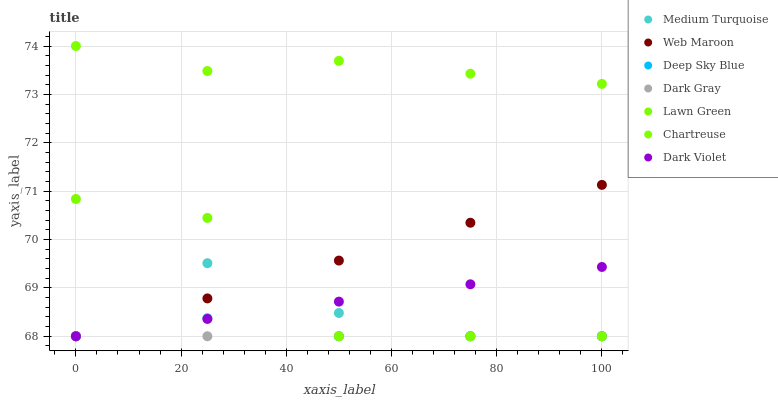Does Dark Gray have the minimum area under the curve?
Answer yes or no. Yes. Does Chartreuse have the maximum area under the curve?
Answer yes or no. Yes. Does Medium Turquoise have the minimum area under the curve?
Answer yes or no. No. Does Medium Turquoise have the maximum area under the curve?
Answer yes or no. No. Is Web Maroon the smoothest?
Answer yes or no. Yes. Is Lawn Green the roughest?
Answer yes or no. Yes. Is Medium Turquoise the smoothest?
Answer yes or no. No. Is Medium Turquoise the roughest?
Answer yes or no. No. Does Lawn Green have the lowest value?
Answer yes or no. Yes. Does Chartreuse have the lowest value?
Answer yes or no. No. Does Chartreuse have the highest value?
Answer yes or no. Yes. Does Medium Turquoise have the highest value?
Answer yes or no. No. Is Web Maroon less than Chartreuse?
Answer yes or no. Yes. Is Chartreuse greater than Web Maroon?
Answer yes or no. Yes. Does Dark Violet intersect Web Maroon?
Answer yes or no. Yes. Is Dark Violet less than Web Maroon?
Answer yes or no. No. Is Dark Violet greater than Web Maroon?
Answer yes or no. No. Does Web Maroon intersect Chartreuse?
Answer yes or no. No. 